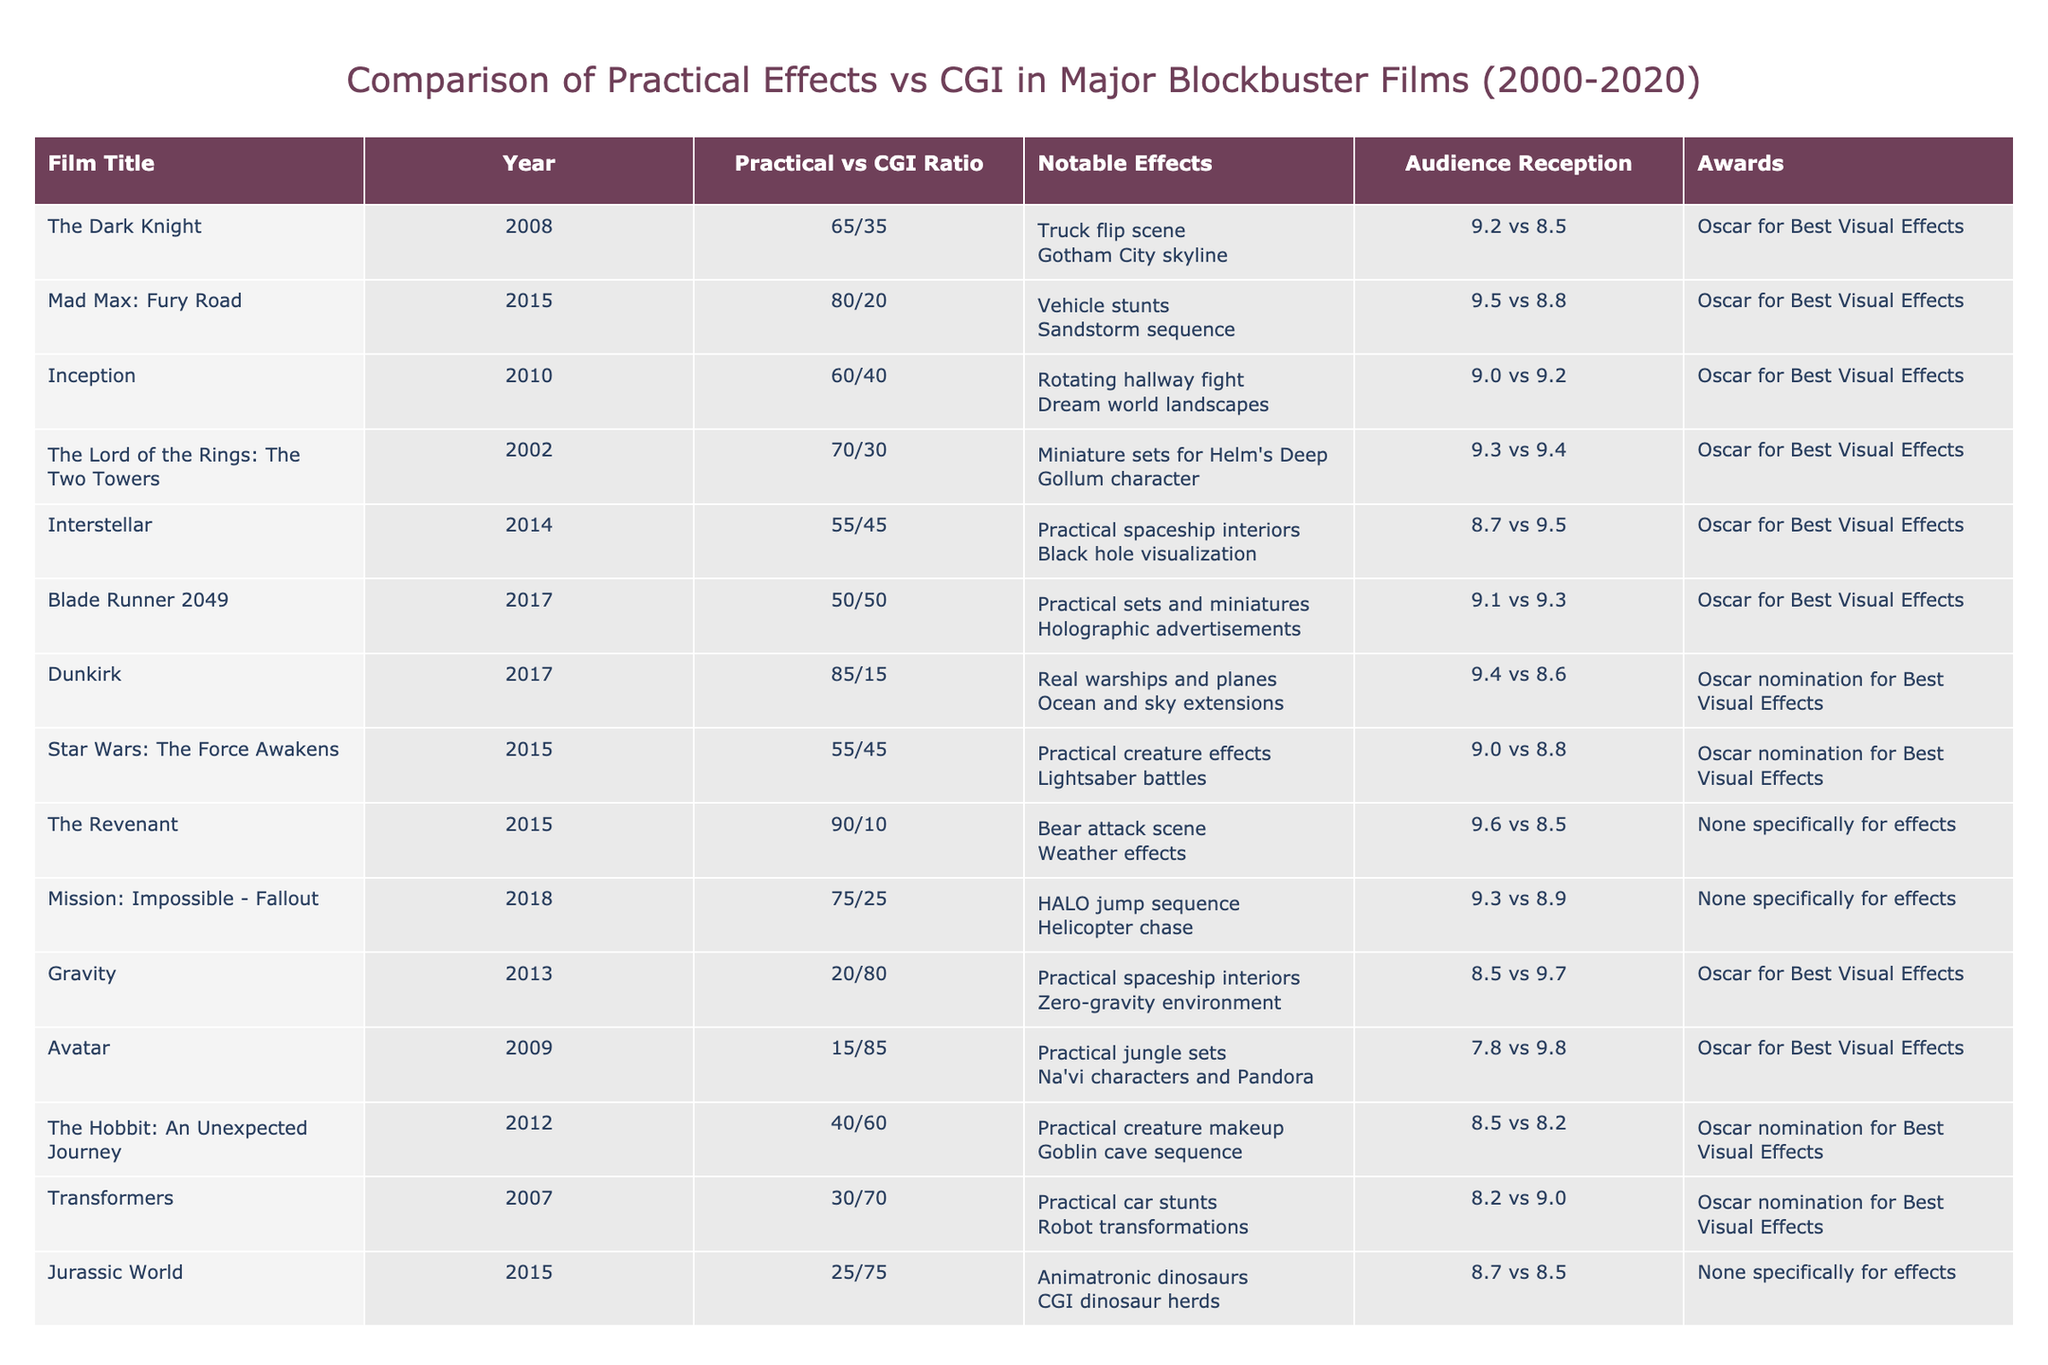What is the film that has the highest practical effects budget percentage? The table shows that "The Revenant" has a practical effects budget of 90%, which is the highest among the listed films.
Answer: The Revenant Which film has the highest audience reception for practical effects? According to the table, "The Revenant" has an audience reception score of 9.6, which is the highest score for practical effects in the listed films.
Answer: The Revenant What is the average practical effects budget percentage across all films in the table? To calculate the average, we sum the practical effects budget percentages: (65 + 80 + 60 + 70 + 55 + 50 + 85 + 55 + 90 + 75 + 20 + 15 + 40 + 30 + 25) = 780. There are 15 films, so the average is 780 / 15 = 52.
Answer: 52 Is "Dunkirk" nominated for an Oscar for Best Visual Effects? The table states that "Dunkirk" received an Oscar nomination for Best Visual Effects, so the answer is yes.
Answer: Yes Which film has a notable CGI effect involving a character and what is the effect? "The Lord of the Rings: The Two Towers" features the character Gollum as a notable CGI effect.
Answer: Gollum character What is the difference in audience reception between practical effects and CGI for "Jurassic World"? "Jurassic World" has a practical reception score of 8.7 and a CGI score of 8.5. The difference is 8.7 - 8.5 = 0.2.
Answer: 0.2 Does any film on the list have a higher CGI effects budget than practical effects budget? Yes, CGI budgets for "Gravity" (80%) and "Avatar" (85%) are higher than their practical effects budgets.
Answer: Yes Which film features a notable practical effect of a bear attack scene and what is its audience reception for that effect? The film "The Revenant" features a bear attack scene as the notable practical effect, and its audience reception score for practical effects is 9.6.
Answer: 9.6 Which film has the largest difference between audience reception for practical vs CGI effects? The film "Avatar" has a difference of 9.8 - 7.8 = 2.0, which is the largest difference between practical and CGI audience reception scores.
Answer: 2.0 